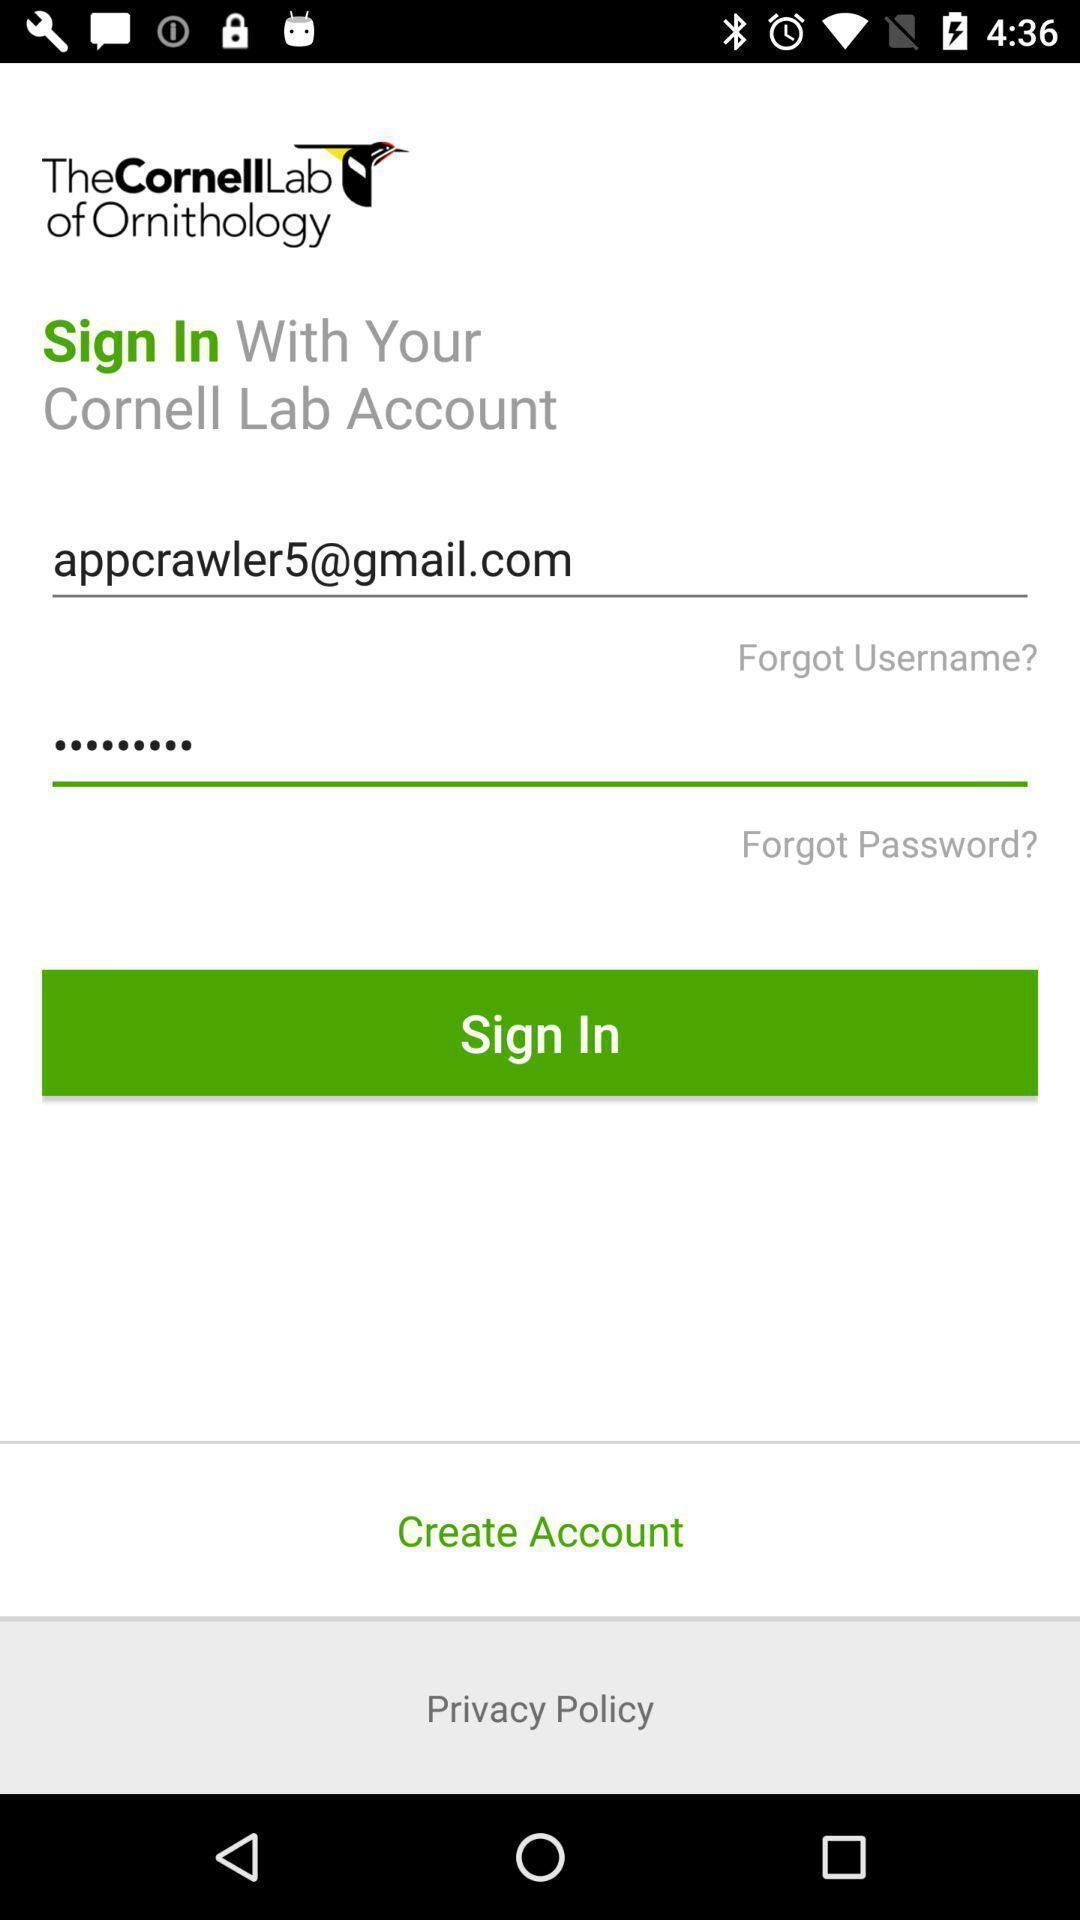Give me a summary of this screen capture. Sign in page. 